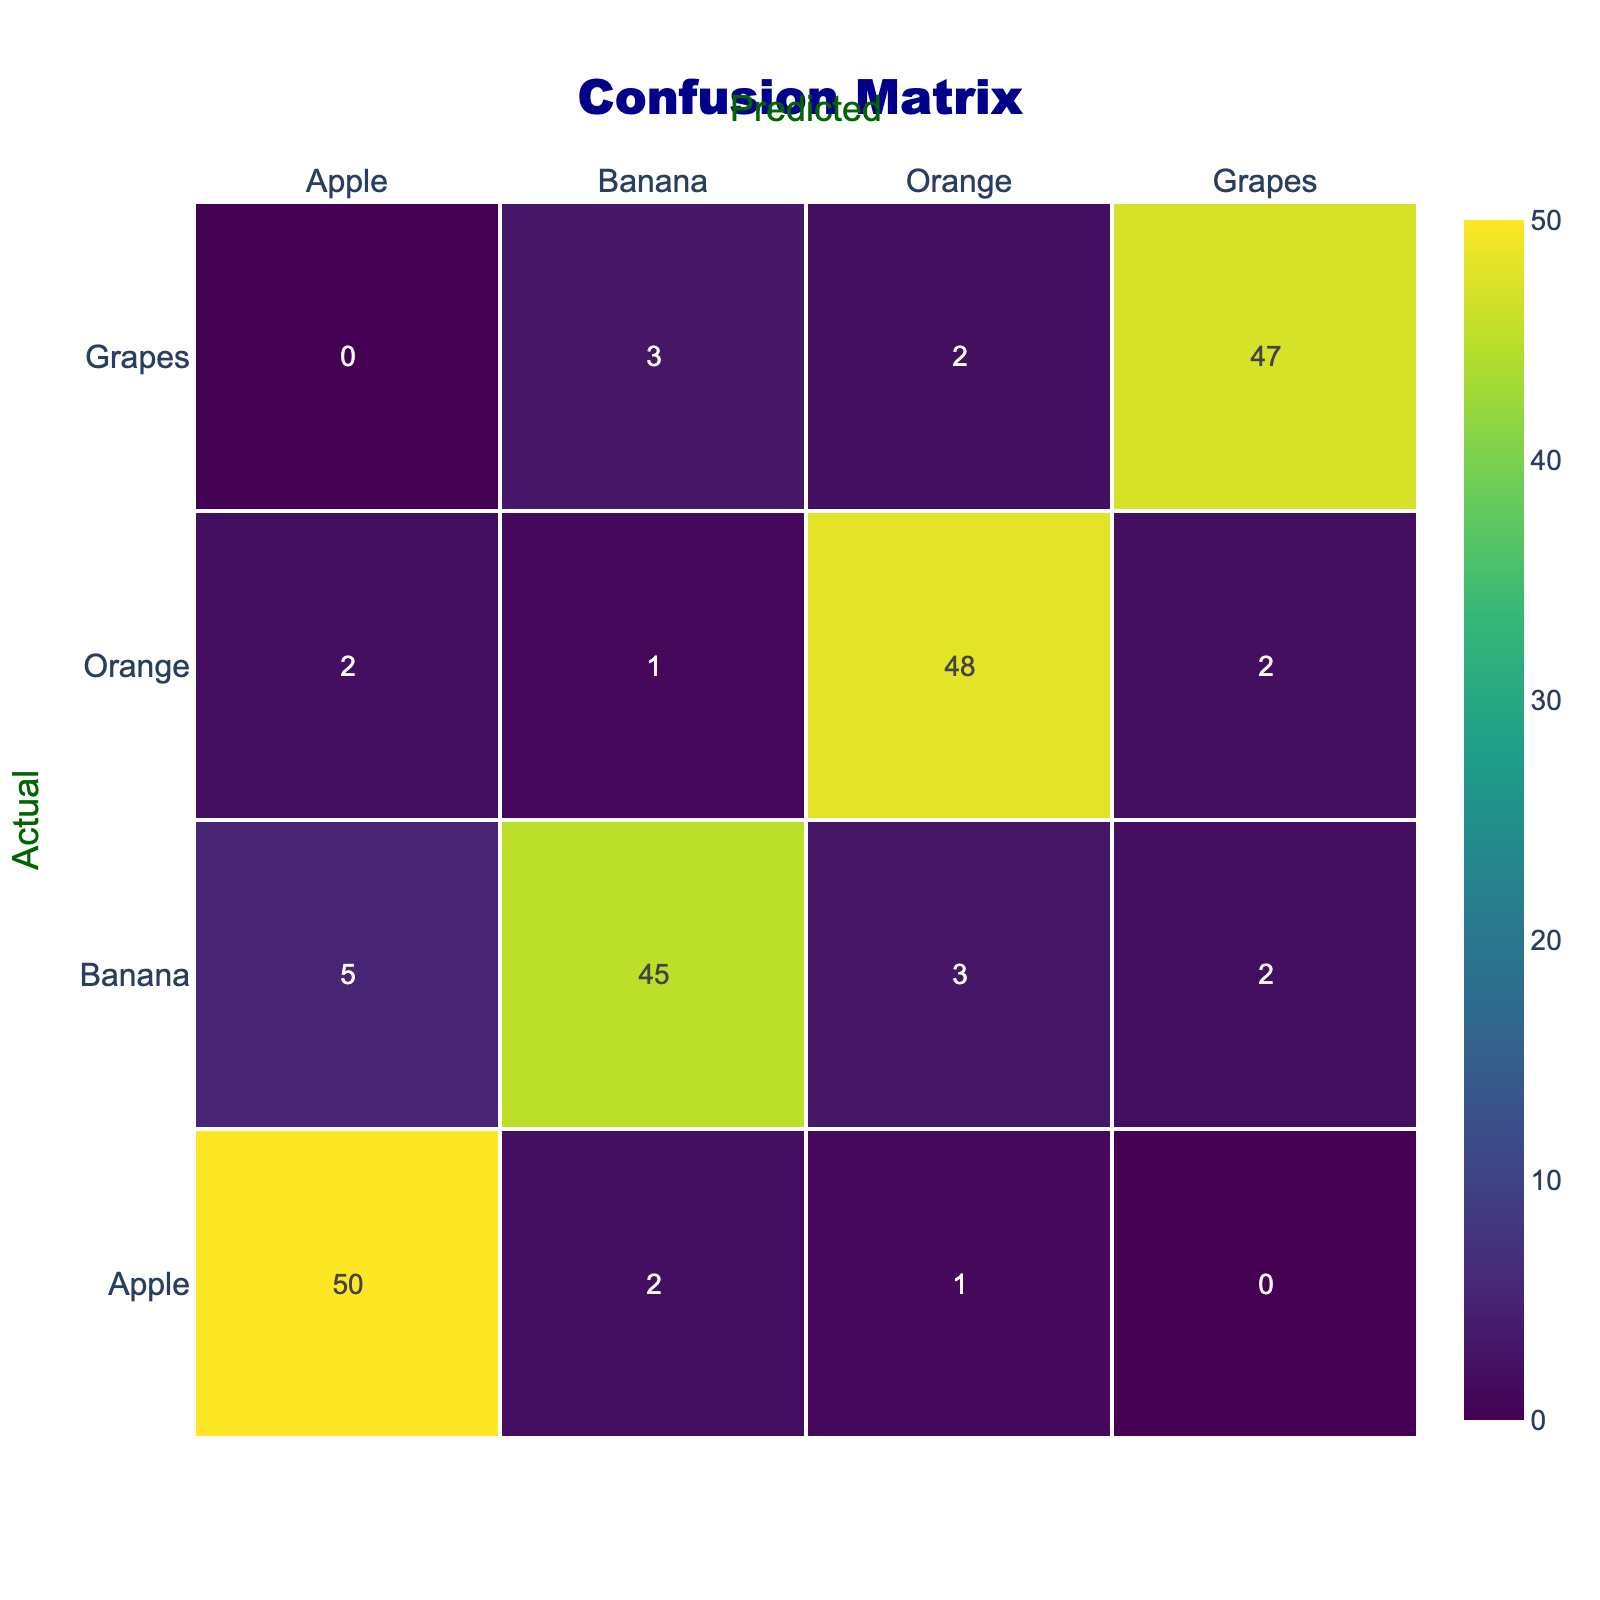What is the total number of instances classified as Grapes? To find the total classified as Grapes, we look at the row for Grapes. The total instances classified as Grapes can be calculated by adding the correctly classified instances (47) and the instances incorrectly classified as other classes (0 + 3 + 2) = 47 + 5 = 52.
Answer: 52 What is the highest number of instances classified correctly for any fruit? We can find the correctly classified instances by looking at the diagonal of the table. The highest number corresponds to Apple, with 50 instances.
Answer: 50 How many instances were predicted incorrectly as Oranges when they were actually Apples? Checking the Apple row, the prediction for Oranges shows 1 instance. This indicates that 1 instance of Apple was incorrectly predicted as Orange.
Answer: 1 Is the number of instances classified as Bananas greater than 40? Looking at the diagonal entry for Bananas, we see that 45 instances were classified correctly, which is indeed greater than 40.
Answer: Yes What is the combined total of instances misclassified as Apples and Oranges? To find the misclassifications for Apples, we look at the Apple row and consider the values 2 (predicted as Banana) and 1 (predicted as Orange), giving us 2 + 1 = 3 instances misclassified as Apples. For Oranges, we look at the Orange row: 2 (predicted as Apple) and 1 (predicted as Banana) give us 2 + 1 = 3 instances misclassified. Therefore, the combined total is 3 (for Apples) + 3 (for Oranges) = 6.
Answer: 6 What is the average number of instances classified correctly across all fruits? To find the average of correctly classified instances, we sum the diagonal values: 50 (Apple) + 45 (Banana) + 48 (Orange) + 47 (Grapes) = 190. There are 4 fruits, so we compute the average by dividing by 4: 190 / 4 = 47.5.
Answer: 47.5 